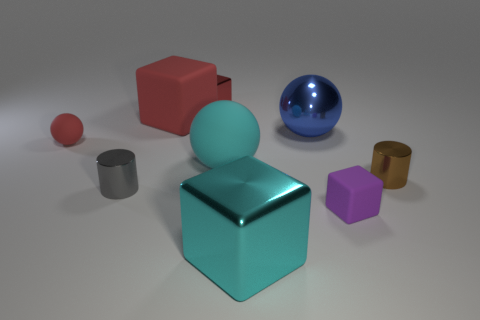What could be the purpose of the collection of objects in this image? This collection of objects, featuring various shapes and materials, could be part of a study on light and shadows, used for educational purposes, or is possibly a set of design elements prepared for a visual composition task. 